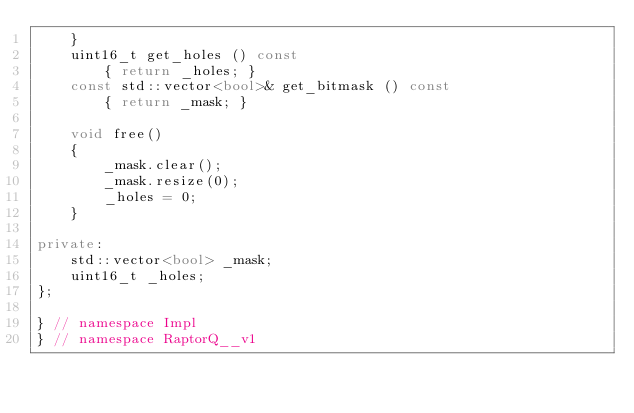Convert code to text. <code><loc_0><loc_0><loc_500><loc_500><_C++_>    }
    uint16_t get_holes () const
        { return _holes; }
    const std::vector<bool>& get_bitmask () const
        { return _mask; }

    void free()
    {
        _mask.clear();
        _mask.resize(0);
        _holes = 0;
    }

private:
    std::vector<bool> _mask;
    uint16_t _holes;
};

} // namespace Impl
} // namespace RaptorQ__v1
</code> 